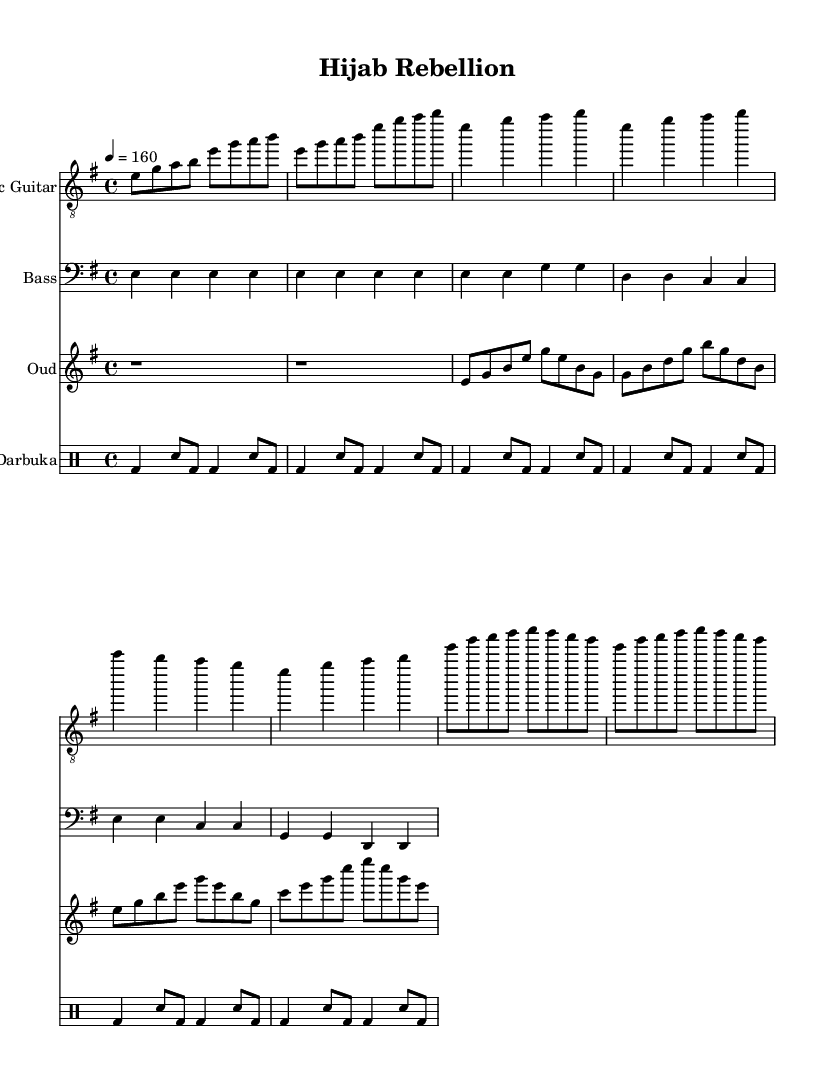What is the key signature of this music? The key signature is E minor, indicated by a single sharp note (F#) which is essential for defining the tonality throughout the piece.
Answer: E minor What is the time signature of this music? The time signature is 4/4, as represented at the beginning, indicating four beats per measure.
Answer: 4/4 What is the tempo marking for this piece? The tempo marking indicates a speed of 160 beats per minute, which defines how fast the music should be played.
Answer: 160 How many measures are in the chorus section? The chorus consists of four measures, as counted from the music notes specifically outlined under the chorus header.
Answer: 4 What instrument plays the traditional Middle Eastern rhythm in this piece? The traditional Middle Eastern rhythm is played by the Darbuka, a percussion instrument known for its distinctive sound.
Answer: Darbuka Do the verses contain repeated musical phrases? Yes, the verses contain repeated phrases, particularly with the rhythmic patterns and melodic lines which convey a sense of cohesion.
Answer: Yes How many distinct sections are there in this piece? There are three distinct sections in this piece: the intro, the verse, and the chorus, each serving a different musical purpose.
Answer: 3 